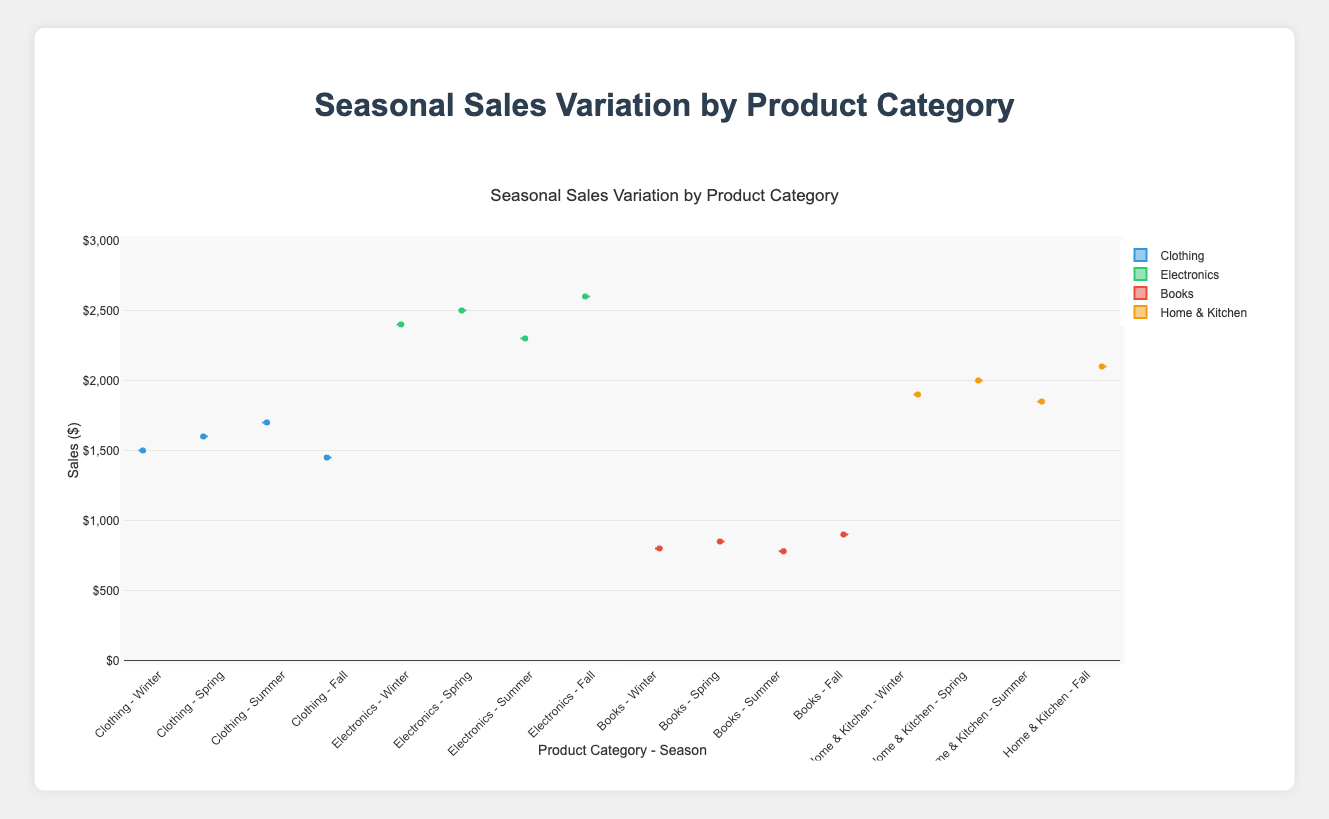What is the title of the plot? The title of the plot is located at the top and serves as a descriptive heading summarizing the content being presented.
Answer: Seasonal Sales Variation by Product Category What is the y-axis title and its range? The y-axis title is present on the left side of the plot and describes what the y-axis represents, while the range indicates the span of values shown on the axis.
Answer: Sales ($), 0 to 3000 Which product category has the highest sales during Summer? To determine the highest sales, you need to look at the position of the highest box plot for Summer. For Summer, the Electronics category shows the highest values compared to Clothing, Books, and Home & Kitchen.
Answer: Electronics Which season has the most consistent sales for the Books category? Consistent sales can typically be inferred from the interquartile range (IQR) size of the box plot. The season with the smallest IQR for Books indicates the most consistent sales.
Answer: Spring Compare the median sales for Clothing in Winter and Fall. Which season had higher sales? To compare, look for the median line inside the box plots for Clothing in Winter and Fall. The Winter median line appears higher than Fall's.
Answer: Winter What is the interquartile range (IQR) of sales for Home & Kitchen in Spring? The IQR is the difference between the third quartile (Q3) and the first quartile (Q1) of the box plot for Home & Kitchen in Spring. From the plot, approximate Q3 and Q1.
Answer: ~150 (Q3: 1850, Q1: 1700) Which product category shows the widest variation in sales during Summer? The variation is shown by the overall height of the box plot including whiskers in Summer. Electronics shows the widest variation.
Answer: Electronics How do the median sales of Electronics in Fall compare to those in Spring? The median sales are represented by the central line in each box plot. The median for Fall is higher than Spring for Electronics.
Answer: Fall What is common about the sales trend for all product categories during Winter? Look for patterns across the different box plots for Winter. All product categories exhibit their relatively higher sales during Winter compared to other seasons.
Answer: Higher sales Based on the overall data, which category shows the least seasonal variation? The least variation can be inferred from the box plot's overall height (less spread). Books have relatively smaller variations across all seasons.
Answer: Books 